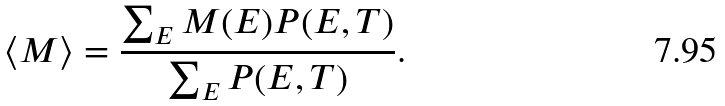Convert formula to latex. <formula><loc_0><loc_0><loc_500><loc_500>\langle M \rangle = \frac { \sum _ { E } M ( E ) P ( E , T ) } { \sum _ { E } P ( E , T ) } .</formula> 